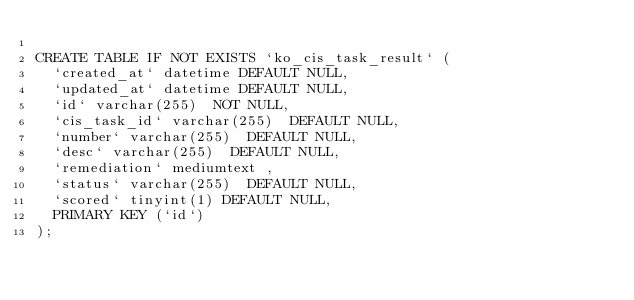Convert code to text. <code><loc_0><loc_0><loc_500><loc_500><_SQL_>
CREATE TABLE IF NOT EXISTS `ko_cis_task_result` (
  `created_at` datetime DEFAULT NULL,
  `updated_at` datetime DEFAULT NULL,
  `id` varchar(255)  NOT NULL,
  `cis_task_id` varchar(255)  DEFAULT NULL,
  `number` varchar(255)  DEFAULT NULL,
  `desc` varchar(255)  DEFAULT NULL,
  `remediation` mediumtext ,
  `status` varchar(255)  DEFAULT NULL,
  `scored` tinyint(1) DEFAULT NULL,
  PRIMARY KEY (`id`)
);</code> 